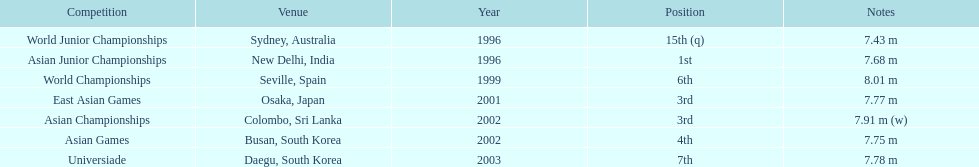How many competitions did he place in the top three? 3. 